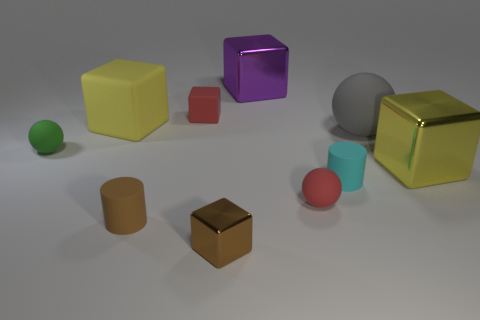Does the cube that is in front of the cyan cylinder have the same material as the small cyan thing?
Make the answer very short. No. What is the color of the tiny block that is made of the same material as the purple thing?
Offer a very short reply. Brown. Is the number of small red balls in front of the brown shiny block less than the number of large yellow rubber cubes right of the green sphere?
Make the answer very short. Yes. Do the big matte object that is left of the large purple thing and the shiny object that is right of the large ball have the same color?
Your response must be concise. Yes. Are there any tiny cyan objects that have the same material as the gray ball?
Ensure brevity in your answer.  Yes. There is a object that is in front of the small brown rubber thing that is to the right of the tiny green matte object; what is its size?
Provide a short and direct response. Small. Are there more tiny red matte objects than gray rubber things?
Offer a very short reply. Yes. There is a red rubber object to the right of the purple block; is it the same size as the brown rubber cylinder?
Offer a very short reply. Yes. What number of tiny spheres are the same color as the small metallic block?
Offer a terse response. 0. Is the shape of the small metallic object the same as the purple thing?
Your answer should be very brief. Yes. 